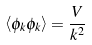<formula> <loc_0><loc_0><loc_500><loc_500>\left \langle \phi _ { k } \phi _ { k } \right \rangle = { \frac { V } { k ^ { 2 } } }</formula> 